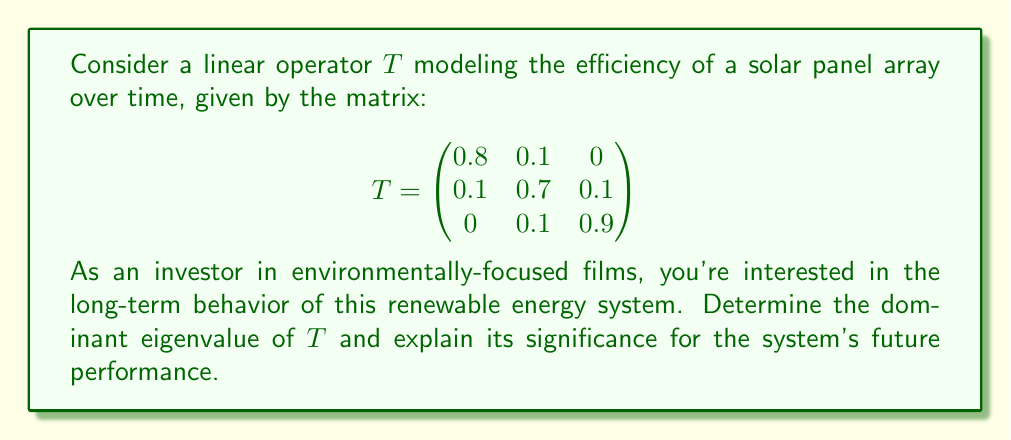Provide a solution to this math problem. To find the eigenvalues of $T$, we need to solve the characteristic equation:

$$\det(T - \lambda I) = 0$$

1) First, let's set up the matrix $T - \lambda I$:

   $$T - \lambda I = \begin{pmatrix}
   0.8-\lambda & 0.1 & 0 \\
   0.1 & 0.7-\lambda & 0.1 \\
   0 & 0.1 & 0.9-\lambda
   \end{pmatrix}$$

2) Now, we calculate the determinant:

   $$(0.8-\lambda)[(0.7-\lambda)(0.9-\lambda) - 0.01] - 0.1[0.1(0.9-\lambda)] + 0 = 0$$

3) Expanding this:

   $(0.8-\lambda)(0.63-1.6\lambda+\lambda^2) - 0.09 + 0.1\lambda = 0$

4) Simplifying:

   $0.504 - 1.28\lambda + 0.8\lambda^2 - 0.63\lambda + 1.6\lambda^2 - \lambda^3 - 0.09 + 0.1\lambda = 0$
   $-\lambda^3 + 2.4\lambda^2 - 1.81\lambda + 0.414 = 0$

5) This cubic equation can be solved using numerical methods. The three roots (eigenvalues) are approximately:

   $\lambda_1 \approx 0.9641$
   $\lambda_2 \approx 0.7359$
   $\lambda_3 \approx 0.7000$

6) The dominant eigenvalue is the largest in magnitude: $\lambda_1 \approx 0.9641$

The significance of this dominant eigenvalue is that it represents the long-term behavior of the system. Since it's close to 1, it indicates that the solar panel array maintains high efficiency over time. This is crucial for sustainable energy production and would be of great interest to an investor in environmentally-focused films.
Answer: $\lambda_1 \approx 0.9641$ 